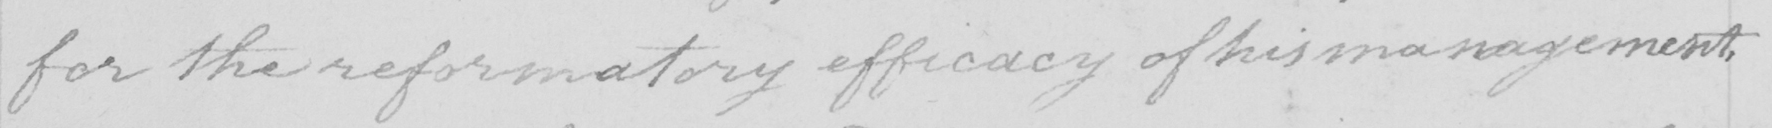Transcribe the text shown in this historical manuscript line. for the reformatory efficacy of him management , 